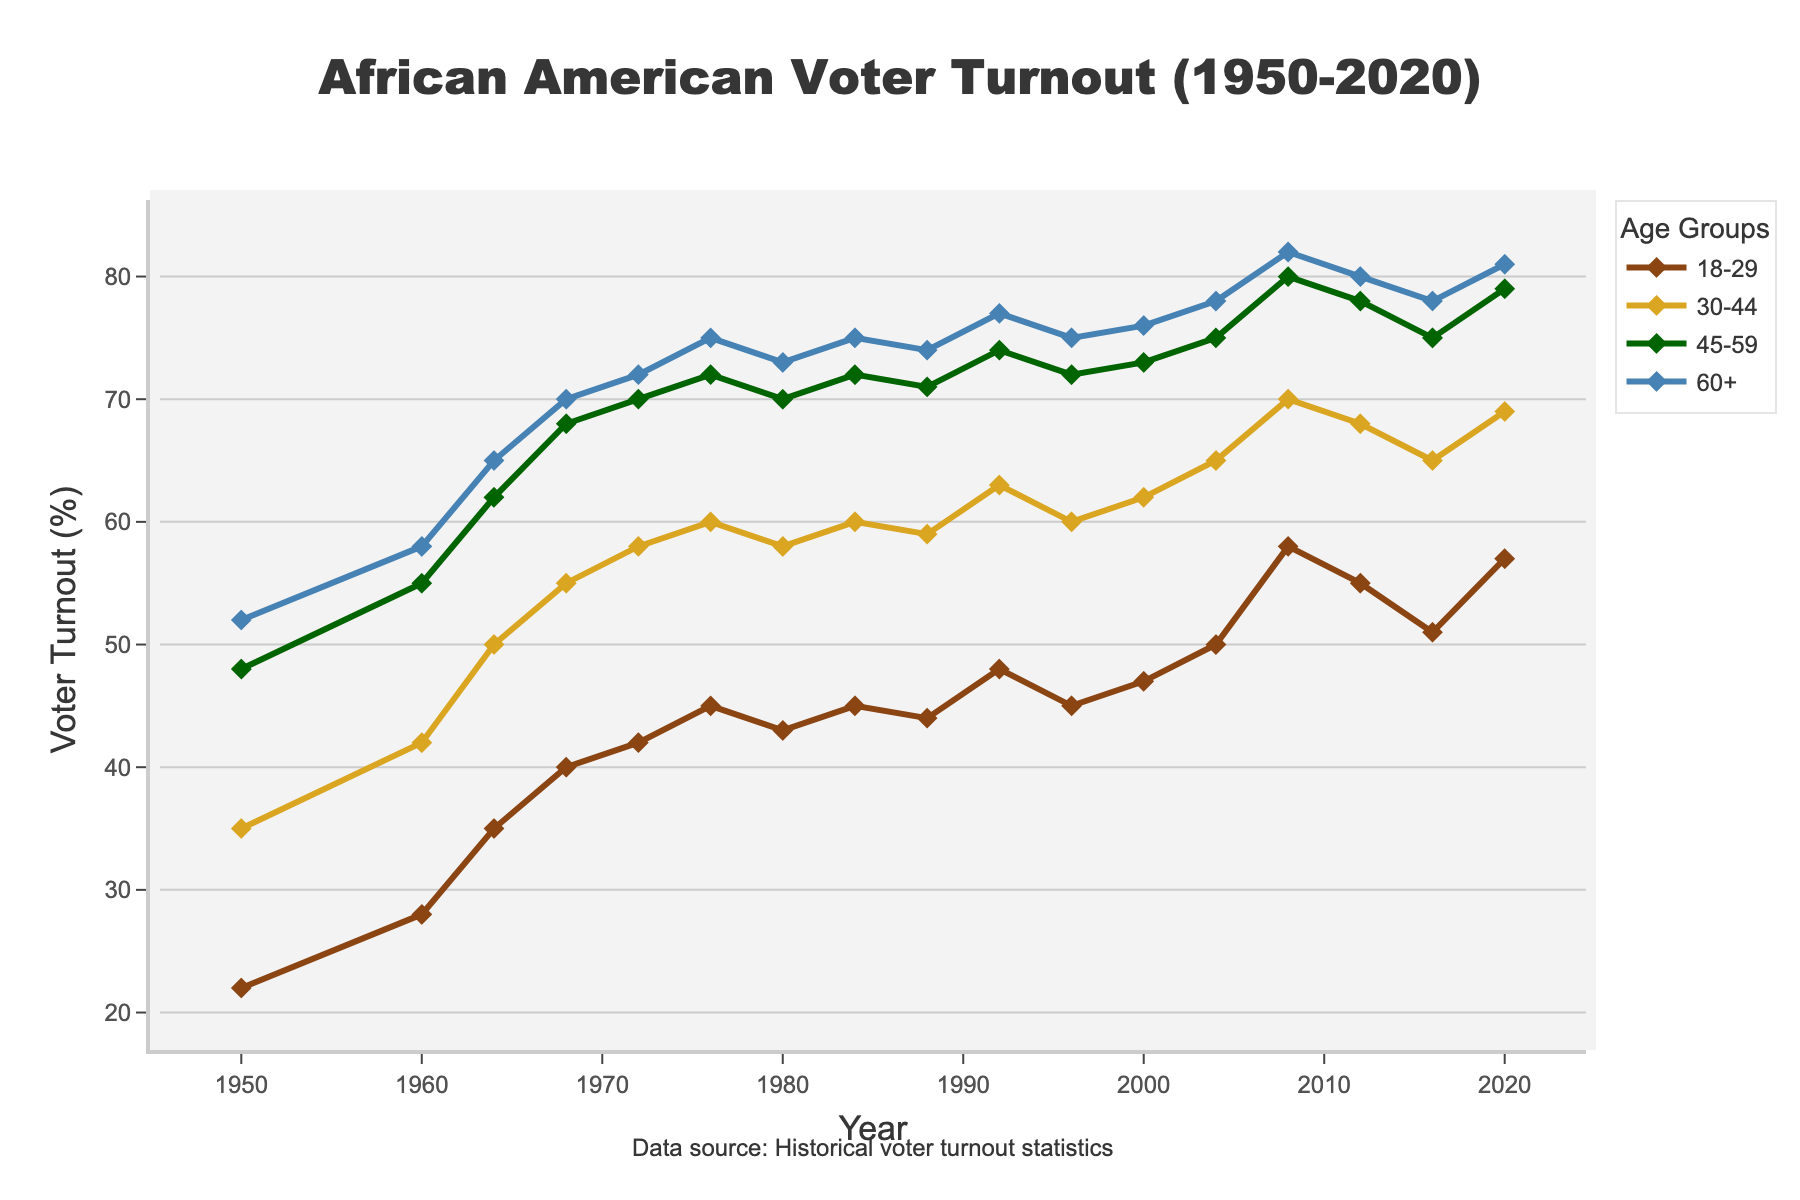How has the voter turnout for the 18-29 age group changed from 1950 to 2020? Compare the voter turnout rates for the years 1950 and 2020 in the 18-29 age group. In 1950, the voter turnout rate was 22%. In 2020, it increased to 57%. Therefore, the change is 57% - 22% = 35%.
Answer: It increased by 35% Which age group had the highest voter turnout in 1968? Look at the voter turnout rates across all age groups for the year 1968. The voter turnout rates are: 18-29 (40%), 30-44 (55%), 45-59 (68%), and 60+ (70%). The highest voter turnout rate is 70% in the 60+ age group.
Answer: 60+ age group What is the average voter turnout rate for the 45-59 age group between 1950 and 2020? To find the average, sum the voter turnout rates for the 45-59 age group from 1950 to 2020, then divide by the number of data points. The rates are [48, 55, 62, 68, 70, 72, 70, 72, 71, 74, 72, 73, 75, 80, 78, 75, 79]. The sum is 1143, and the number of years is 17. 1143 / 17 = 67.24.
Answer: 67.24% What can you say about the trend of voter turnout for the 60+ age group from 1950 to 2020? Look at the plot for the 60+ age group. The trend shows a consistent increase from 52% in 1950 to 81% in 2020. This indicates a steady upward trend in voter turnout over the years.
Answer: It shows a steady increase In which year did the 18-29 age group see the largest voter turnout rate increase compared to the previous election? Calculate the differences in voter turnout rates for consecutive elections in the 18-29 age group. For instance, 1960-1950: 28-22 = 6, 1964-1960: 35-28 = 7, 1968-1964: 40-35 = 5, etc. The largest increase is between 2004 and 2008, where the turnout increased by 8% (58-50).
Answer: Between 2004 and 2008 Which age groups showed a consistent voter turnout increase at every election year from 1950 to 2020? Identify the age groups where the voter turnout rates increase at every recorded election year. From the data, the 60+ age group consistently increased from 1950 (52%) to 2020 (81%) without any decrease.
Answer: 60+ age group Compare the voter turnout rates in 2008 for all age groups. Which group had the smallest turnout, and what was it? Look at the 2008 voter turnout rates: 18-29 (58%), 30-44 (70%), 45-59 (80%), 60+ (82%). The smallest turnout is in the 18-29 age group with 58%.
Answer: 18-29 age group, 58% What is the overall trend of voter turnout among African Americans from 1950 to 2020 across all age groups? Observe the general trend for all age groups from 1950 to 2020. Each age group shows a clear increasing trend over time. This indicates an overall rise in voter participation among African Americans.
Answer: Increasing trend across all age groups 